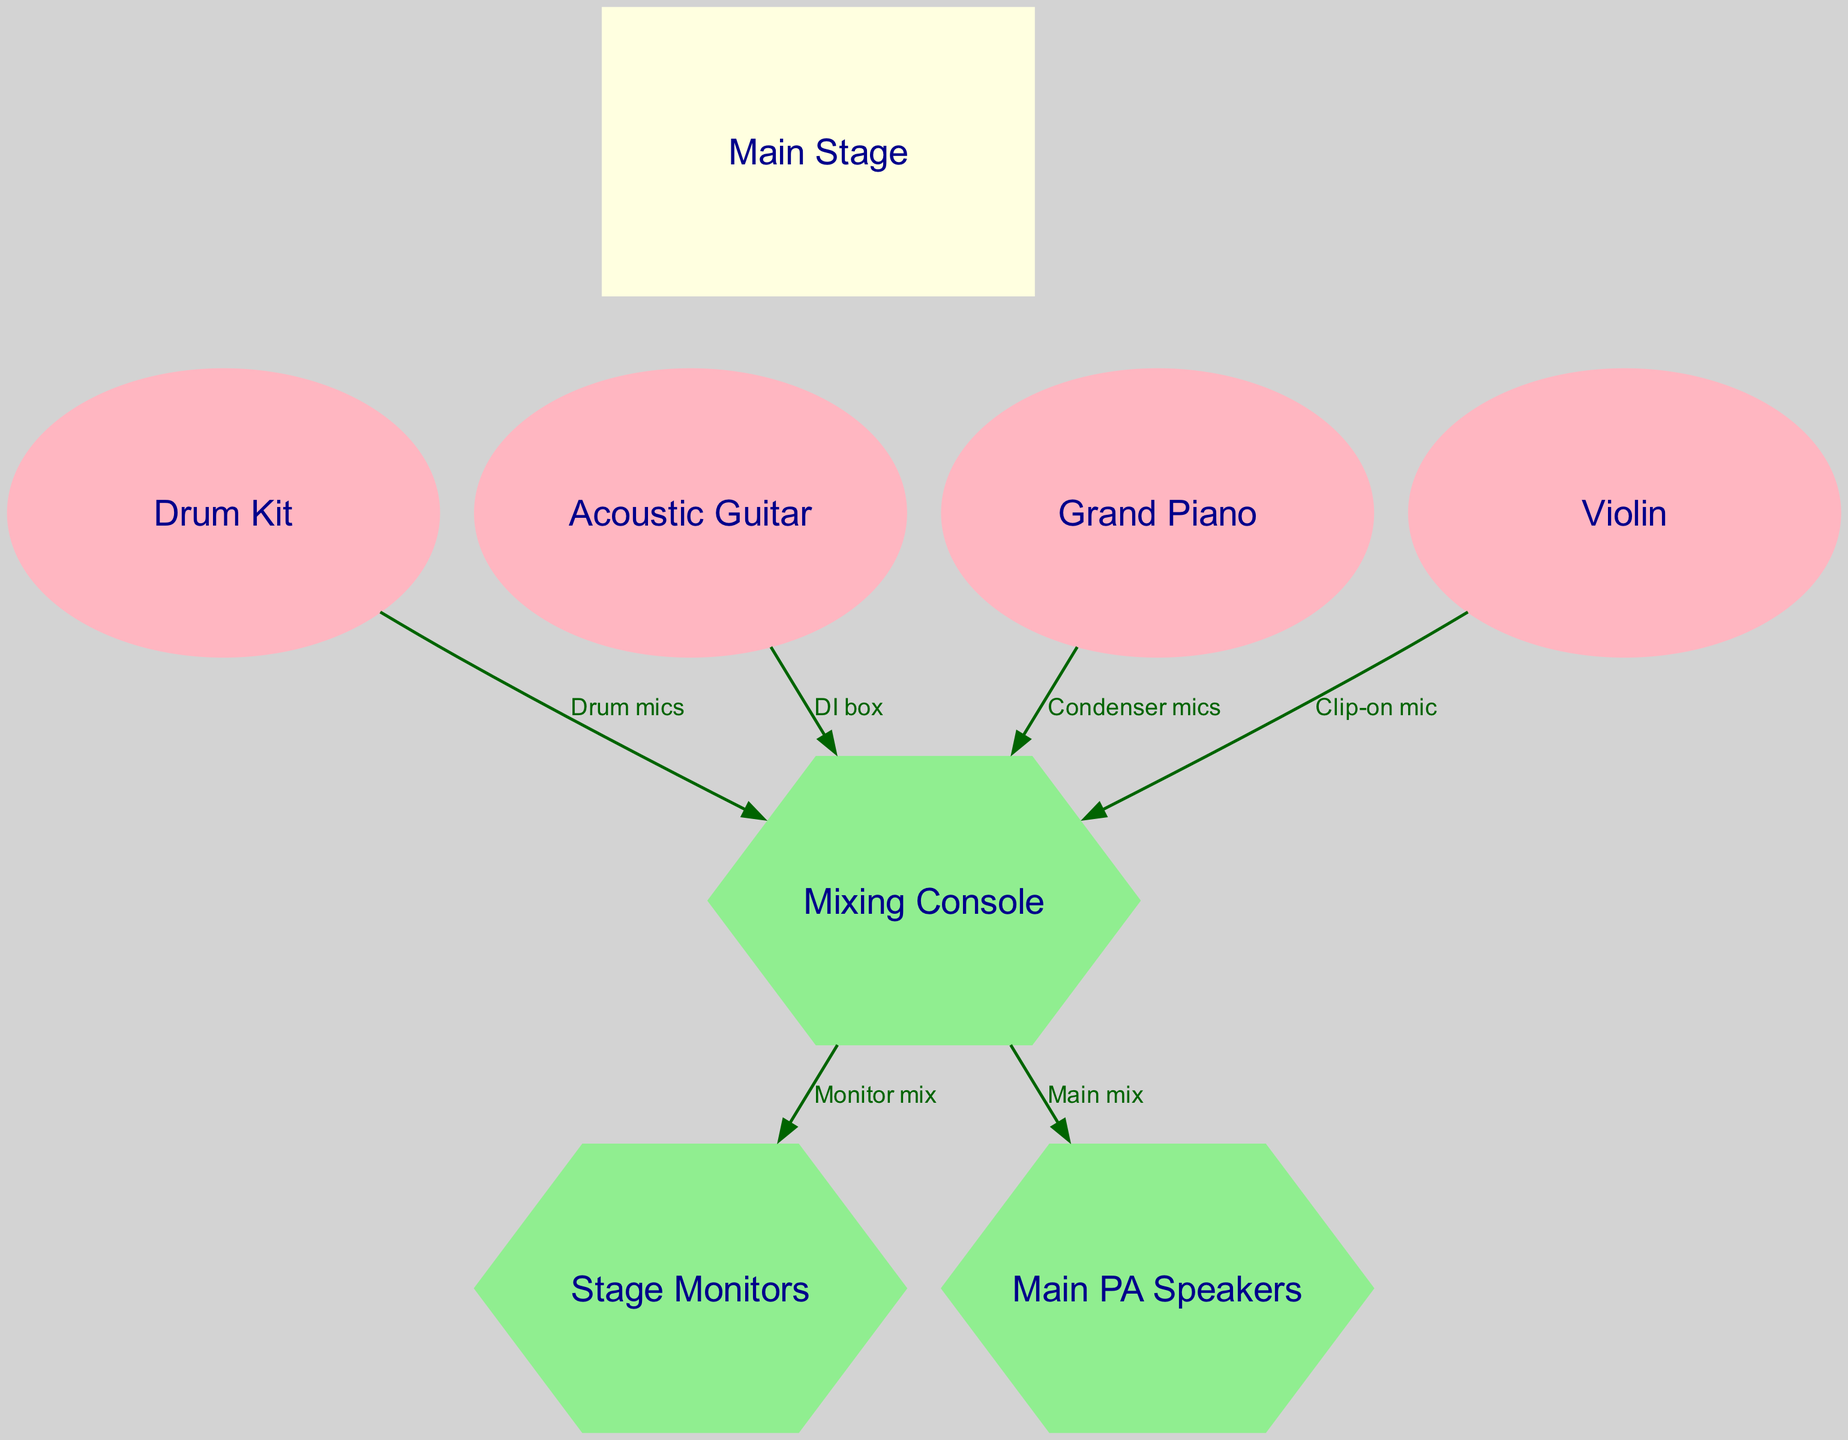What's the total number of nodes in the diagram? The diagram contains eight nodes: Main Stage, Drum Kit, Acoustic Guitar, Grand Piano, Violin, Mixing Console, Stage Monitors, and Main PA Speakers. Counting each one gives us a total of eight nodes.
Answer: Eight Which instrument connects to the Mixing Console via a Clip-on mic? The diagram shows that the instrument connected to the Mixing Console via a Clip-on mic is the Violin. This can be identified by tracing the edge from the Violin node to the Mixer node, labeled accordingly.
Answer: Violin What kind of mic is used for the Grand Piano? The Grand Piano is connected to the Mixing Console using Condenser mics, as indicated by the label on the edge leading from the piano to the mixer.
Answer: Condenser mics How many instruments are directly connected to the Mixing Console? The diagram indicates that four instruments (Drum Kit, Acoustic Guitar, Grand Piano, and Violin) are directly connected to the Mixing Console through their respective microphones and interfaces. Counting these connections leads to the answer.
Answer: Four What does the Mixing Console output to? The Mixing Console outputs to two destinations: Stage Monitors and Main PA Speakers. The edges labeled "Monitor mix" and "Main mix" illustrate this dual output path.
Answer: Stage Monitors and Main PA Speakers Which instrument uses a DI box to connect to the Mixing Console? The Acoustic Guitar is connected to the Mixing Console through a DI box. This can be identified in the diagram, where the edge from the guitar to the mixer is labeled "DI box."
Answer: Acoustic Guitar What is the relationship between the Main Stage and the instruments placed on it? The Main Stage serves as the central area where all instruments (Drum Kit, Acoustic Guitar, Grand Piano, Violin) are positioned. It connects to each instrument with invisible edges, signifying their placement on the stage.
Answer: Central area for instruments In what shape is the Mixing Console represented in the diagram? The Mixing Console is represented as a hexagon in the diagram. This shape is distinct and indicates its role within the setup.
Answer: Hexagon 